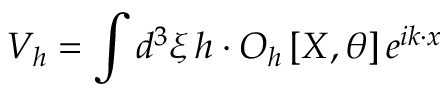Convert formula to latex. <formula><loc_0><loc_0><loc_500><loc_500>V _ { h } = \int d ^ { 3 } \xi \, h \cdot O _ { h } \left [ X , \theta \right ] e ^ { i k \cdot x }</formula> 